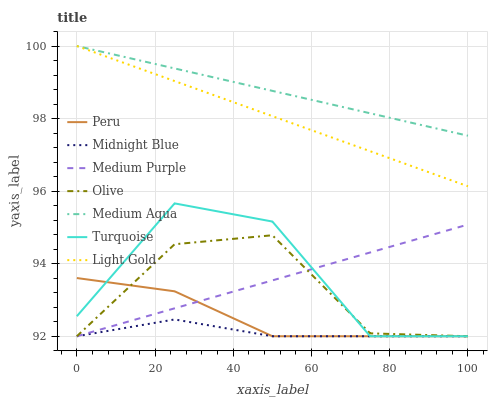Does Midnight Blue have the minimum area under the curve?
Answer yes or no. Yes. Does Medium Aqua have the maximum area under the curve?
Answer yes or no. Yes. Does Medium Purple have the minimum area under the curve?
Answer yes or no. No. Does Medium Purple have the maximum area under the curve?
Answer yes or no. No. Is Light Gold the smoothest?
Answer yes or no. Yes. Is Turquoise the roughest?
Answer yes or no. Yes. Is Midnight Blue the smoothest?
Answer yes or no. No. Is Midnight Blue the roughest?
Answer yes or no. No. Does Medium Aqua have the lowest value?
Answer yes or no. No. Does Medium Purple have the highest value?
Answer yes or no. No. Is Midnight Blue less than Light Gold?
Answer yes or no. Yes. Is Medium Aqua greater than Olive?
Answer yes or no. Yes. Does Midnight Blue intersect Light Gold?
Answer yes or no. No. 